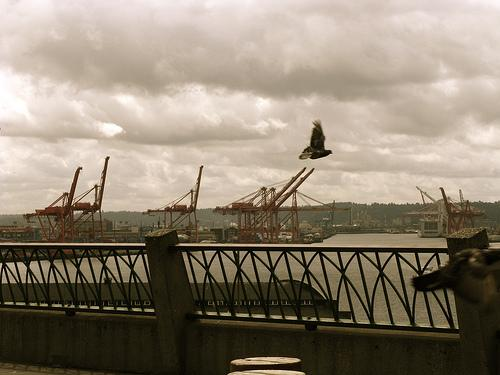Describe the key elements of the image in a single sentence. The image features a bridge with orange cranes, grey cloudy skies, industrial machines, and a bird flying above. Tell me what the main focus of the image is and note any prominent colors or features. The image focuses on a bridge with large orange cranes on its left and right side, a cloudy sky above, and industrial machines near the body of water below the bridge. Describe the atmosphere of the image and highlight any major elements. The image has an industrial atmosphere, showcasing a bridge with large orange cranes, grey clouds in the sky, and a row of industrial machines near the water. List down the important objects in the image along with their characteristics. Bridge with metal railing, large orange cranes, row of industrial machines, cloudy skies, body of water, bird with wings spread, concrete wall of bridge. Briefly describe the architectural and engineering components of the image. The image contains a bridge with metal and concrete components, large orange cranes, a dock, industrial machines, and the top of a plastic table. Provide a concise description for the scene depicted in the image. The scene is a view of a bridge with large orange cranes, cloudy skies and industrial machines surrounding a body of water. Provide a brief description related to the weather in the image. The sky is covered with grey clouds suggesting a gloomy or overcast day. Using the given object coordinates, explain the relative positions of significant objects in the image. The bridge is above the body of water, which has a dock and industrial machines nearby; large orange cranes are on each side of the bridge, while a birdis flying above it. Mention the essential details of the image and describe the overall theme. The image features a bridge, large orange cranes, industrial machines near a body of water, and a cloudy sky, exhibiting an industrial and gloomy atmosphere. Mention the most significant objects in the image and their positions. Significant objects include orange cranes on both sides of the bridge, industrial machines near the water, a bird flying in the sky, and a dock near the water. 